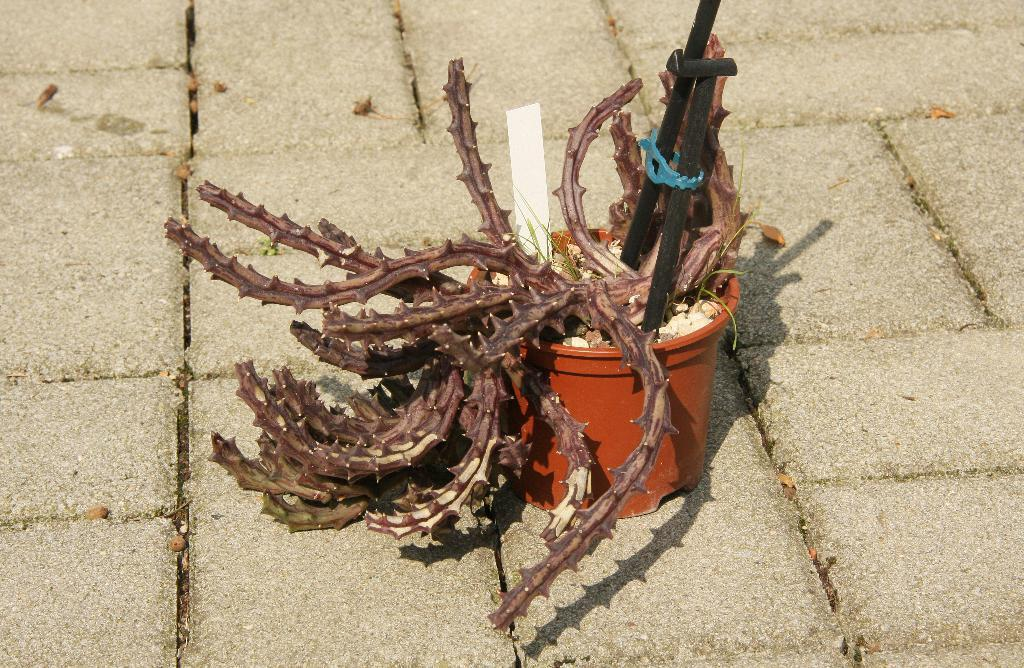What type of living organism can be seen in the image? There is a plant in the image. What is the plant placed in? There is a plant pot in the image. What are the two long, thin objects in the image? There are two rods in the image. What is the primary setting visible in the image? The background of the image is ground. What is the stranger's tendency when brushing their teeth in the image? There is no stranger or brushing activity present in the image. 